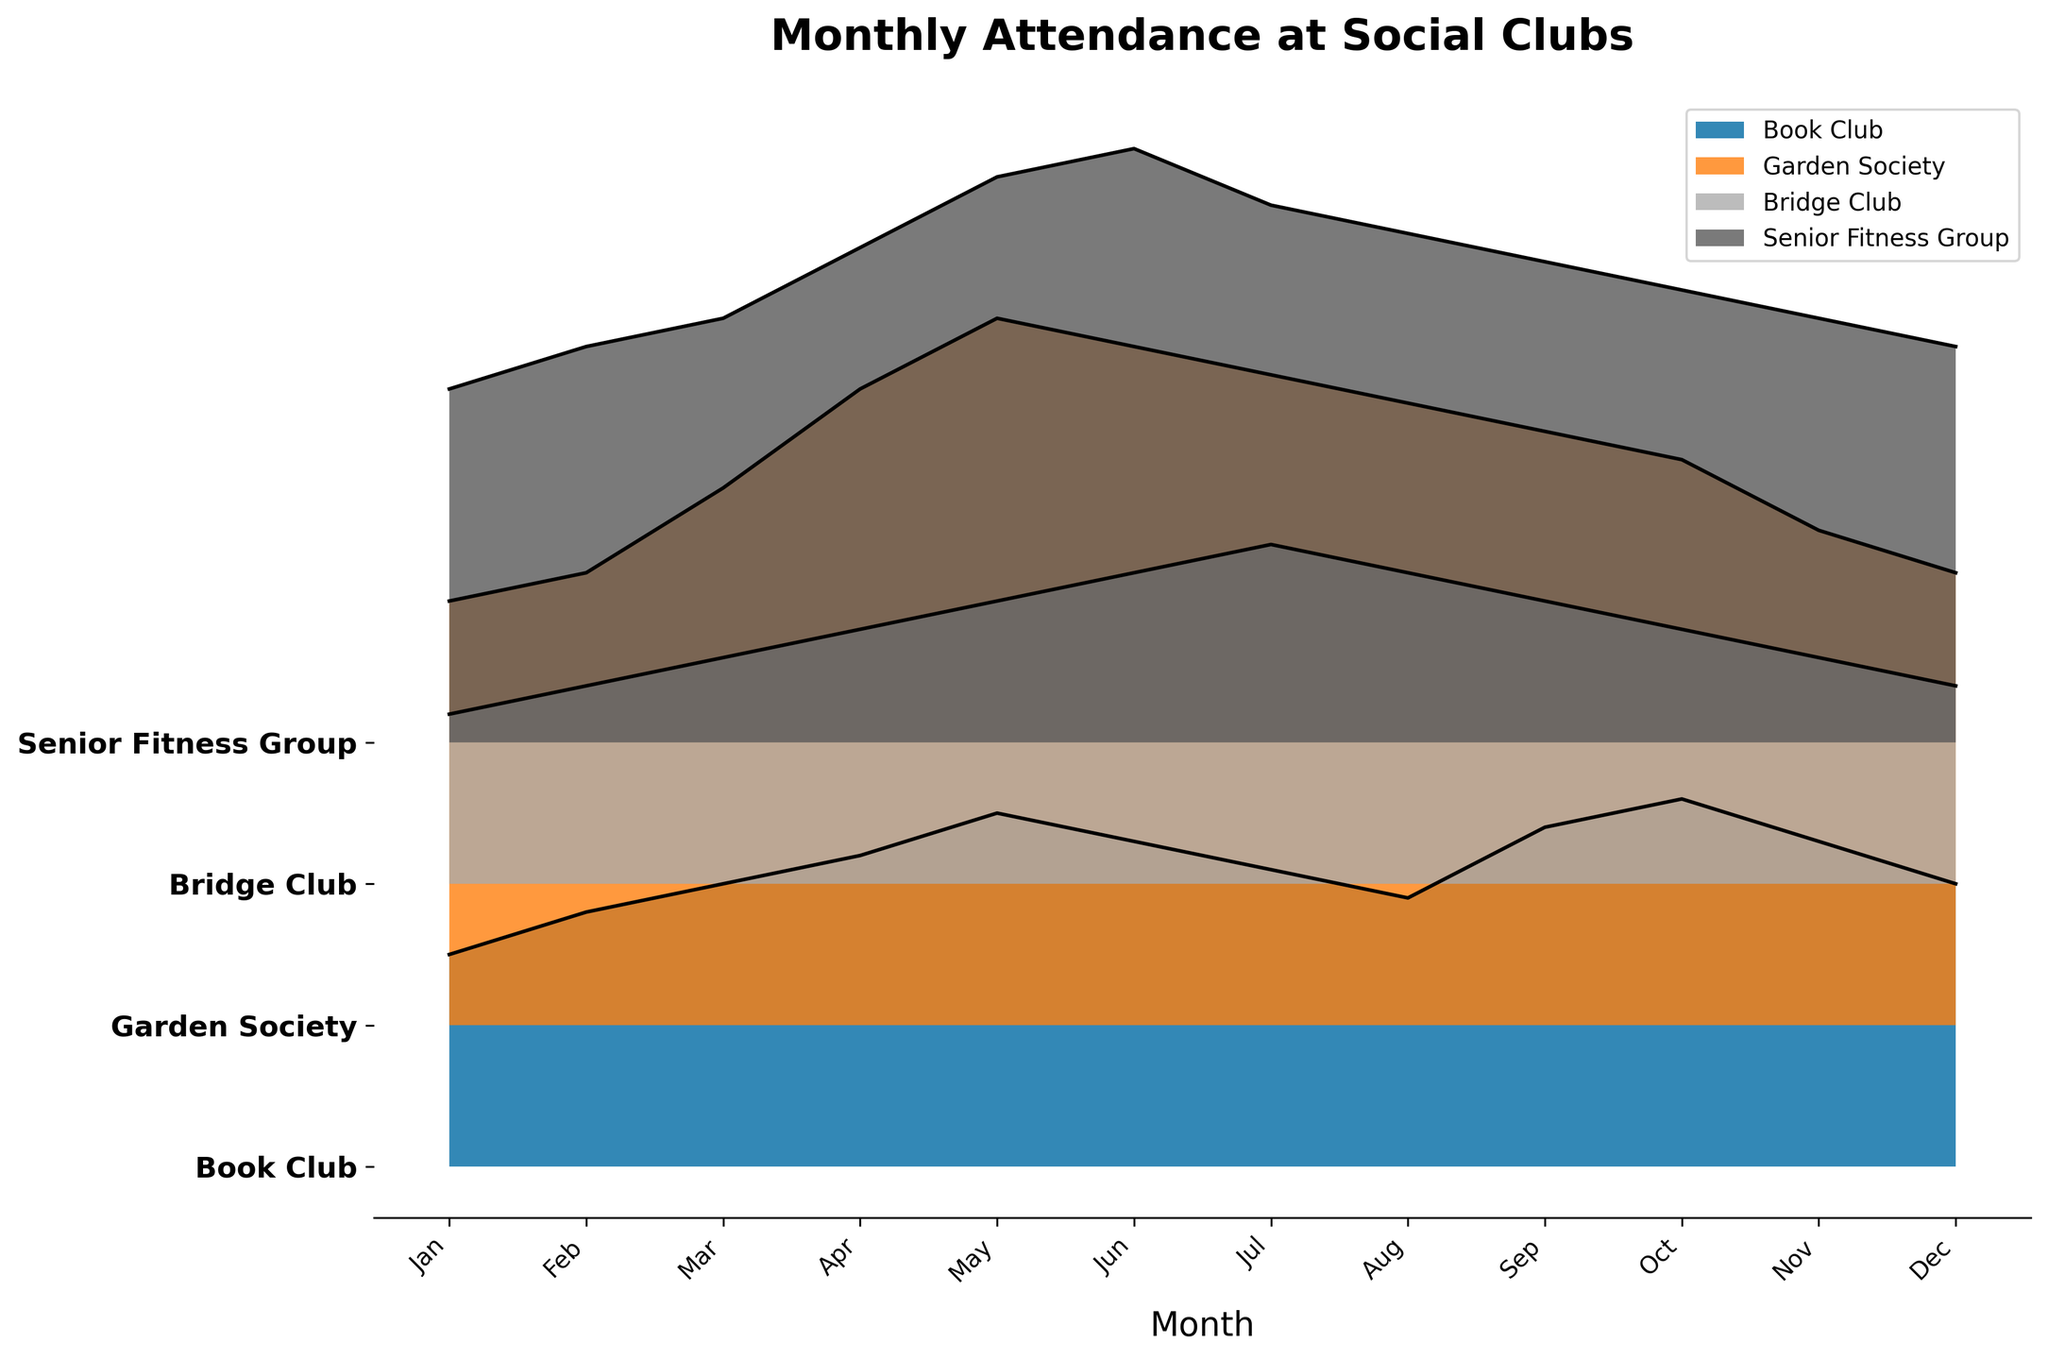What is the title of the figure? The title of the figure is located at the top. It is a straightforward question as the title is prominently displayed above the plot.
Answer: Monthly Attendance at Social Clubs Which club has the highest peak attendance in any month? To determine which club has the highest peak attendance, observe the maximum value reached by each club's ridgeline. The Garden Society reaches the highest peak.
Answer: Garden Society In which month did the Book Club have its highest attendance? For the Book Club, identify the month with the highest peak on its ridgeline. The peak occurs in October.
Answer: October Approximately how much did the attendance for the Garden Society increase from January to May? Subtract the January attendance for the Garden Society (30) from the May attendance (50) to find the increase. 50 - 30 = 20
Answer: 20 Which club shows the most consistent attendance throughout the year? Consistency can be observed by the relatively small variations in the ridgeline. The Bridge Club has the least fluctuation, indicating the most consistent attendance.
Answer: Bridge Club Compare the peak attendance months of the Book Club and the Garden Society. Which months are they? Look at the ridgelines for both clubs and identify their peak months. The Book Club peaks in October, while the Garden Society peaks in May.
Answer: October (Book Club), May (Garden Society) What is the difference in attendance between the Senior Fitness Group and the Bridge Club in June? Check the ridgelines for both the Senior Fitness Group and the Bridge Club in June. Subtract the Bridge Club's attendance (22) from the Senior Fitness Group's attendance (42). 42 - 22 = 20
Answer: 20 Which clubs showed a decline in attendance from July to December? Observe the ridgelines for each club from July to December. All clubs except the Book Club show a decline in attendance.
Answer: Garden Society, Bridge Club, Senior Fitness Group 